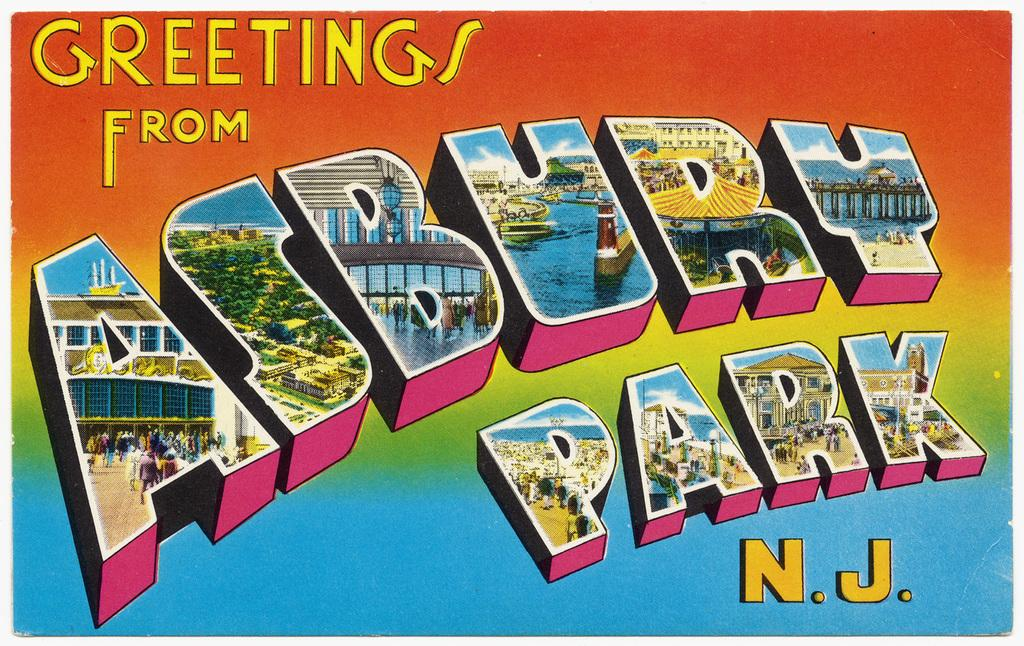<image>
Render a clear and concise summary of the photo. a postcard that says 'greetings from asbury park N.j.' 